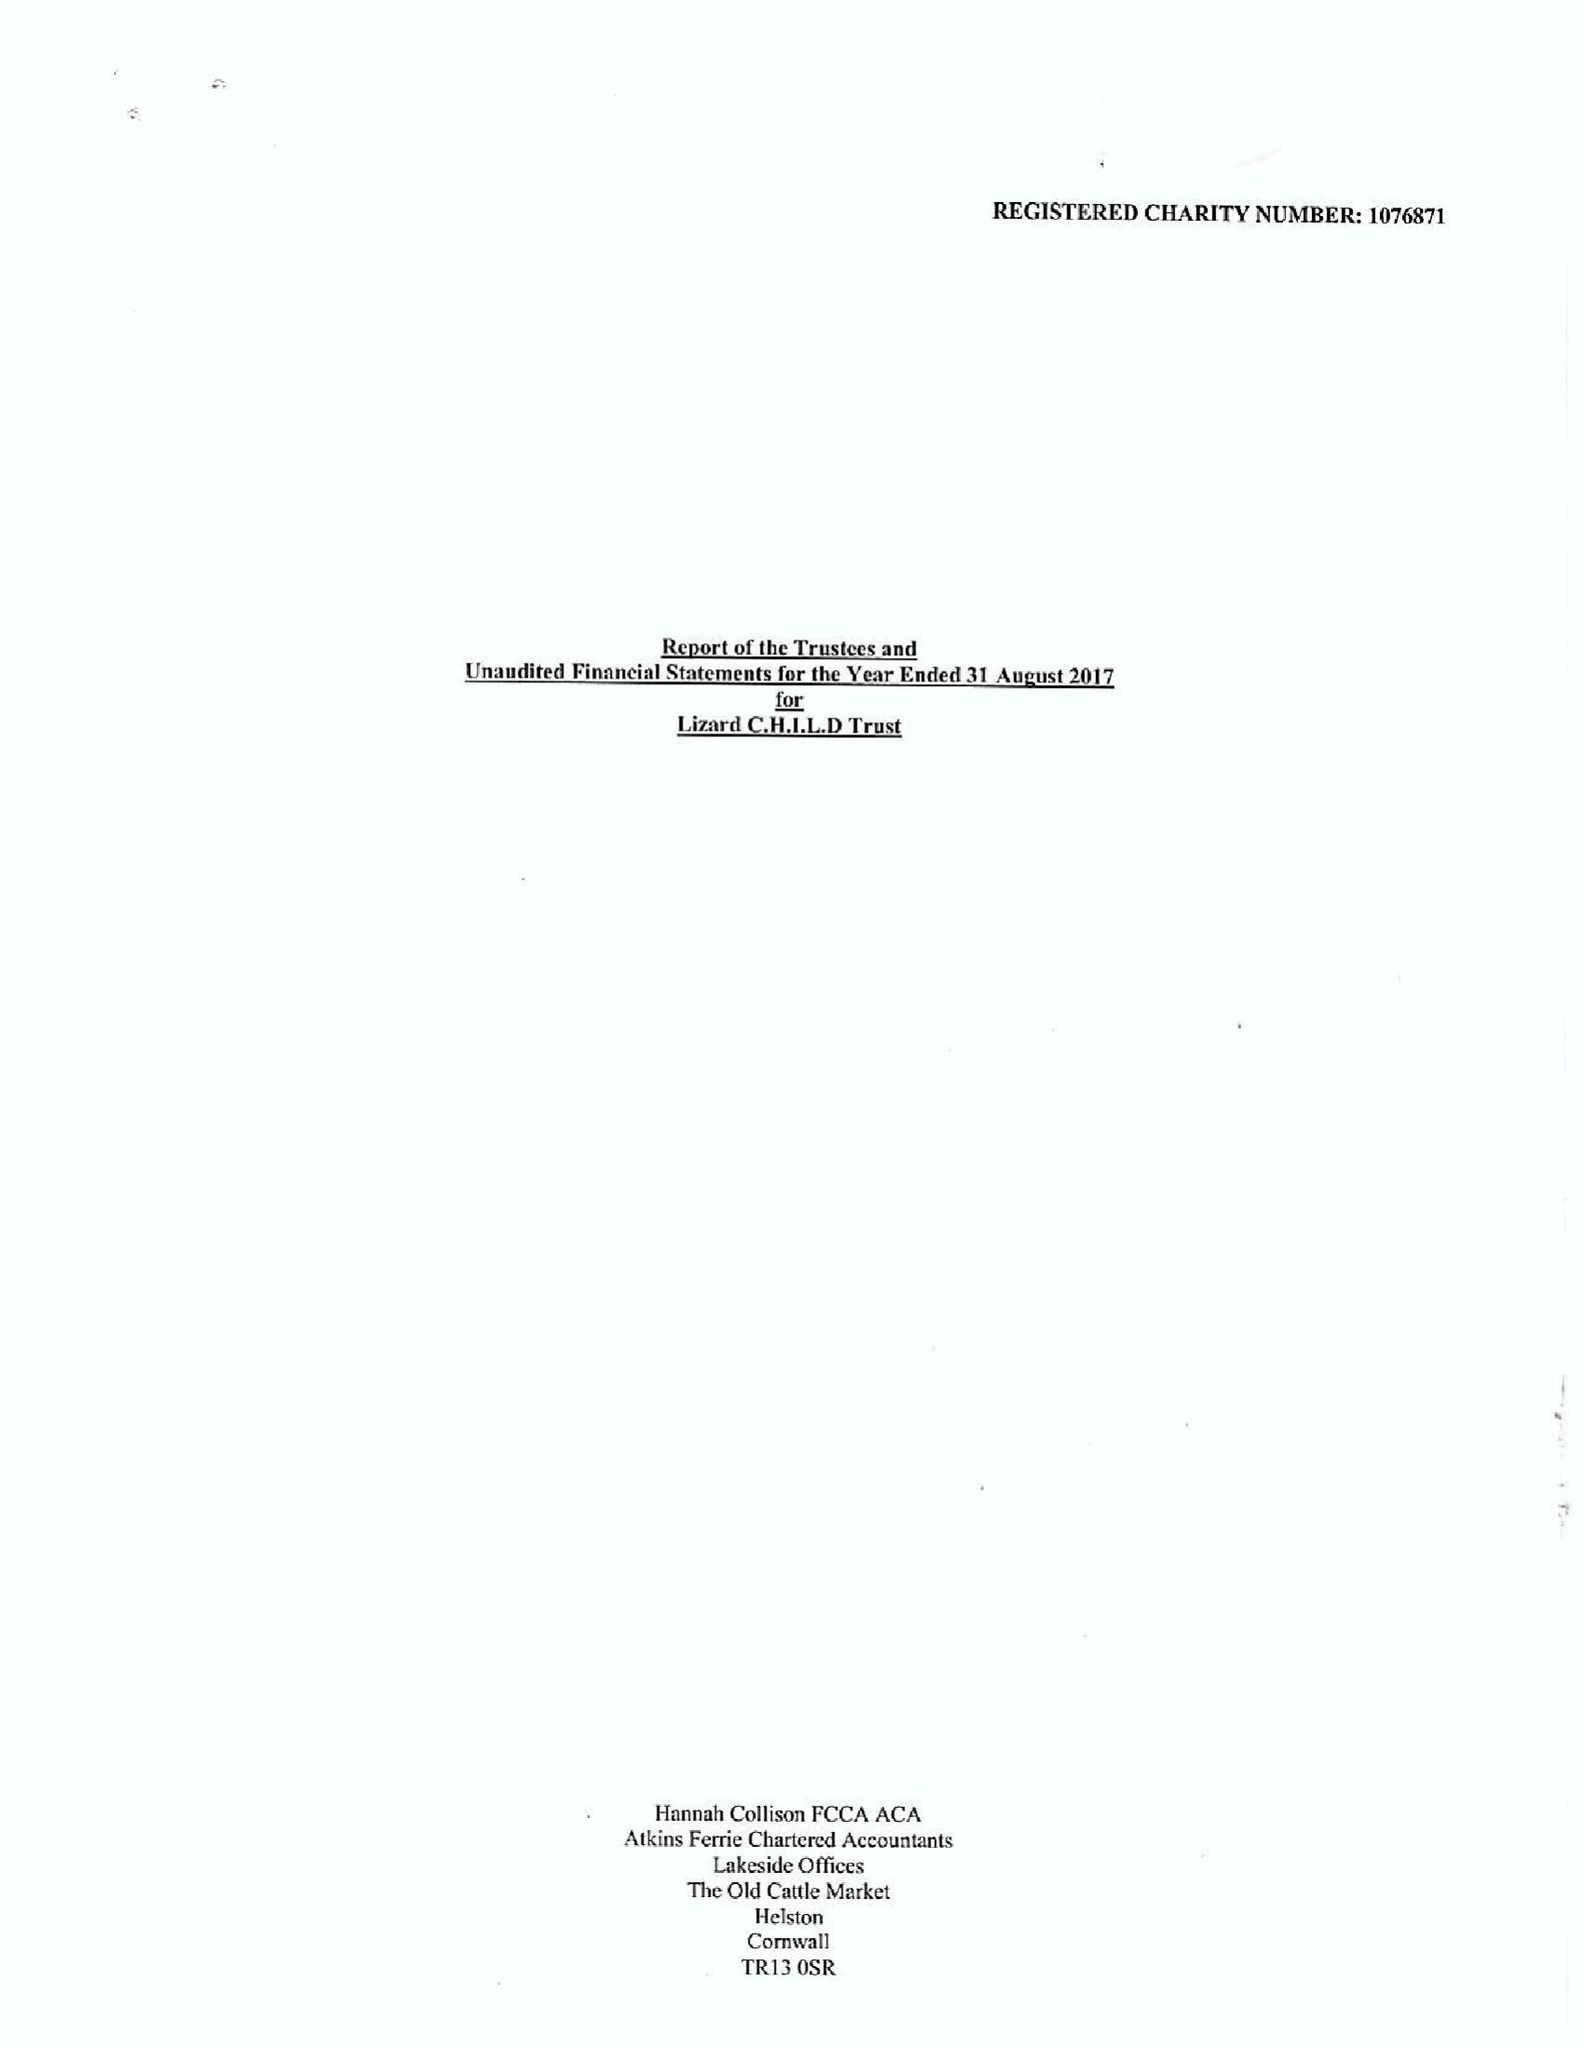What is the value for the address__post_town?
Answer the question using a single word or phrase. HELSTON 